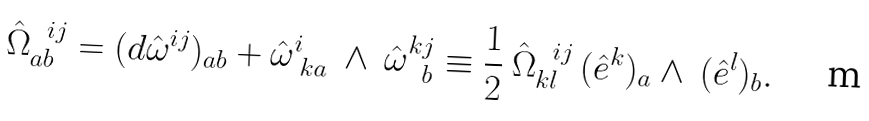<formula> <loc_0><loc_0><loc_500><loc_500>\hat { \Omega } _ { a b } ^ { \ \ i j } = ( d \hat { \omega } ^ { i j } ) _ { a b } + \hat { \omega } ^ { i } _ { \ k a } \ \wedge \ \hat { \omega } ^ { k j } _ { \ \ b } \equiv \frac { 1 } { 2 } \ \hat { \Omega } ^ { \ \ i j } _ { k l } \ ( \hat { e } ^ { k } ) _ { a } \wedge \ ( \hat { e } ^ { l } ) _ { b } .</formula> 